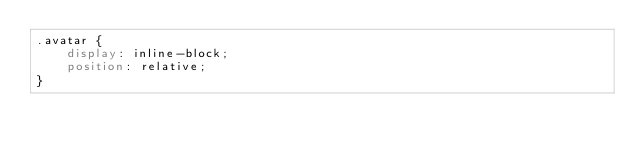<code> <loc_0><loc_0><loc_500><loc_500><_CSS_>.avatar {
    display: inline-block;
    position: relative;
}
</code> 